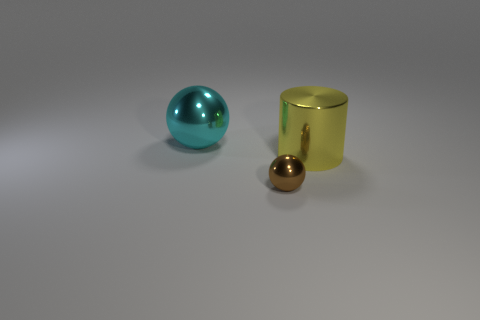Add 1 large blue spheres. How many objects exist? 4 Subtract all balls. How many objects are left? 1 Add 3 large blue matte cubes. How many large blue matte cubes exist? 3 Subtract 0 red blocks. How many objects are left? 3 Subtract all tiny metallic objects. Subtract all tiny spheres. How many objects are left? 1 Add 1 big yellow cylinders. How many big yellow cylinders are left? 2 